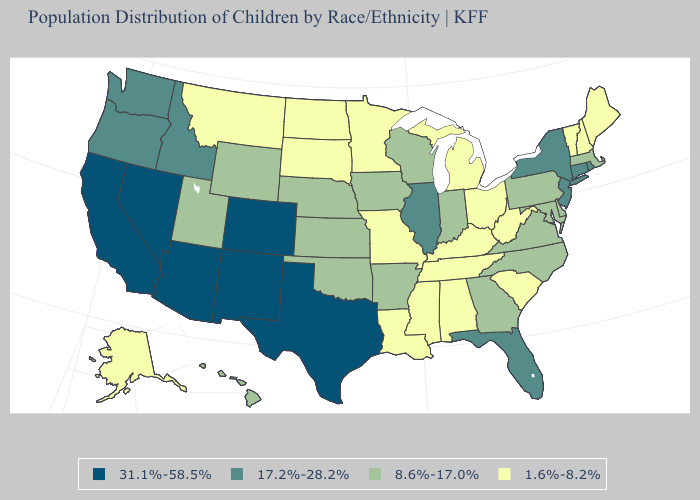What is the value of New York?
Quick response, please. 17.2%-28.2%. Does Arizona have the highest value in the West?
Write a very short answer. Yes. What is the highest value in the MidWest ?
Write a very short answer. 17.2%-28.2%. Does Hawaii have the same value as Minnesota?
Write a very short answer. No. Name the states that have a value in the range 8.6%-17.0%?
Keep it brief. Arkansas, Delaware, Georgia, Hawaii, Indiana, Iowa, Kansas, Maryland, Massachusetts, Nebraska, North Carolina, Oklahoma, Pennsylvania, Utah, Virginia, Wisconsin, Wyoming. What is the value of West Virginia?
Write a very short answer. 1.6%-8.2%. What is the value of Montana?
Keep it brief. 1.6%-8.2%. Does the map have missing data?
Write a very short answer. No. Which states have the lowest value in the USA?
Keep it brief. Alabama, Alaska, Kentucky, Louisiana, Maine, Michigan, Minnesota, Mississippi, Missouri, Montana, New Hampshire, North Dakota, Ohio, South Carolina, South Dakota, Tennessee, Vermont, West Virginia. What is the highest value in states that border Ohio?
Give a very brief answer. 8.6%-17.0%. Name the states that have a value in the range 1.6%-8.2%?
Give a very brief answer. Alabama, Alaska, Kentucky, Louisiana, Maine, Michigan, Minnesota, Mississippi, Missouri, Montana, New Hampshire, North Dakota, Ohio, South Carolina, South Dakota, Tennessee, Vermont, West Virginia. What is the value of Rhode Island?
Give a very brief answer. 17.2%-28.2%. Does Minnesota have the highest value in the USA?
Write a very short answer. No. What is the value of Delaware?
Short answer required. 8.6%-17.0%. Name the states that have a value in the range 8.6%-17.0%?
Give a very brief answer. Arkansas, Delaware, Georgia, Hawaii, Indiana, Iowa, Kansas, Maryland, Massachusetts, Nebraska, North Carolina, Oklahoma, Pennsylvania, Utah, Virginia, Wisconsin, Wyoming. 